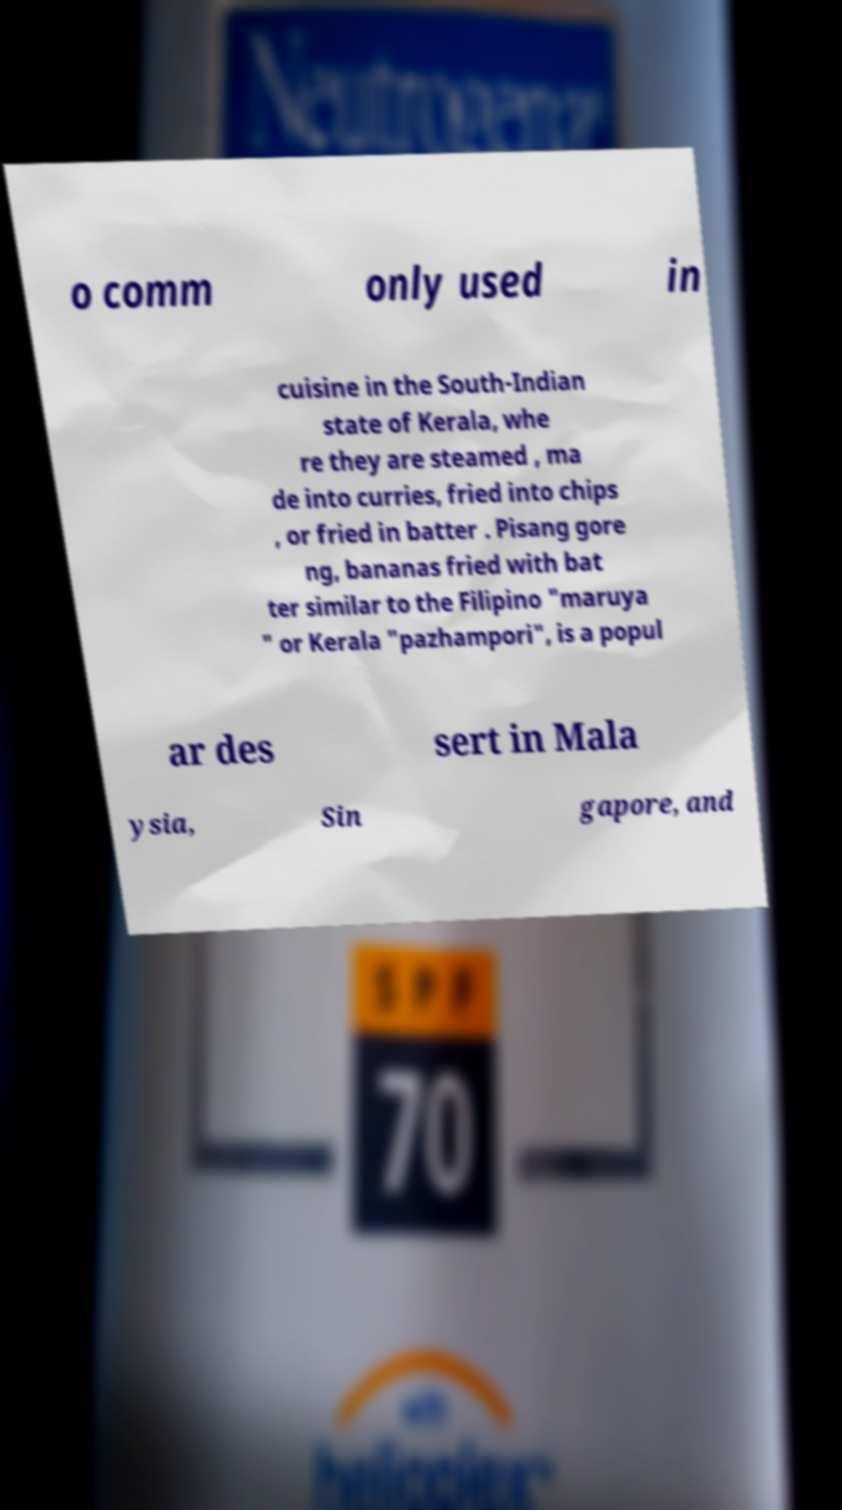Can you read and provide the text displayed in the image?This photo seems to have some interesting text. Can you extract and type it out for me? o comm only used in cuisine in the South-Indian state of Kerala, whe re they are steamed , ma de into curries, fried into chips , or fried in batter . Pisang gore ng, bananas fried with bat ter similar to the Filipino "maruya " or Kerala "pazhampori", is a popul ar des sert in Mala ysia, Sin gapore, and 